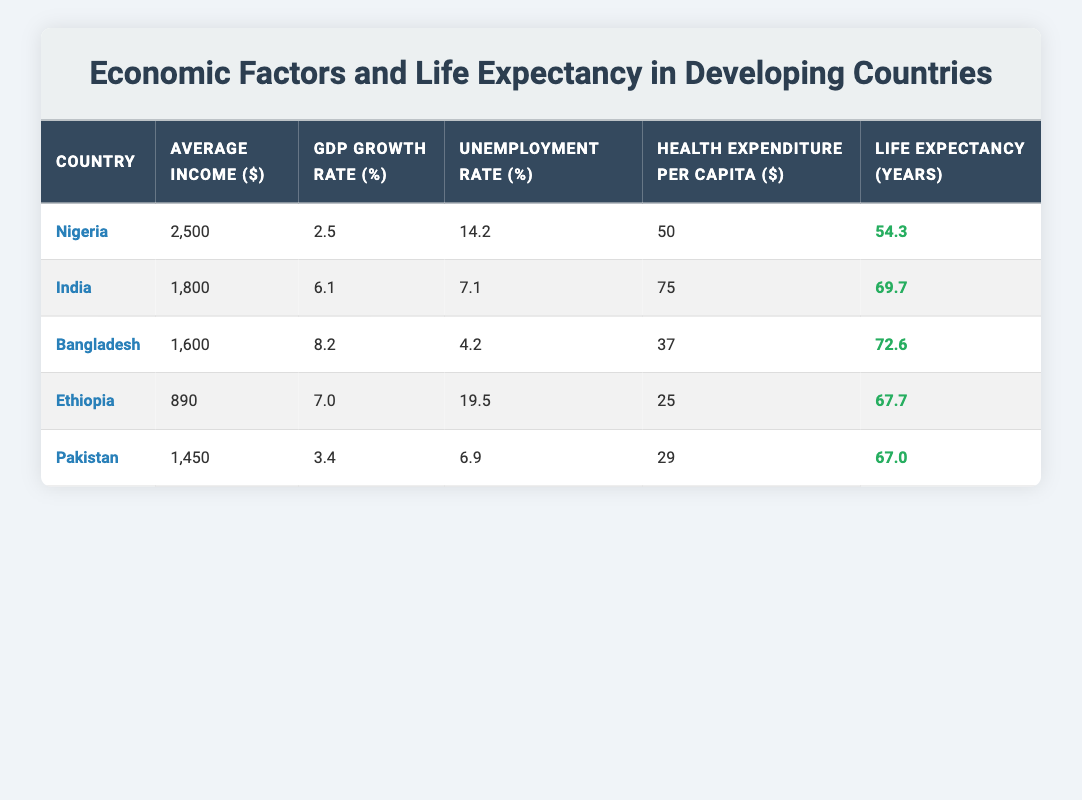What is the life expectancy of Nigeria? The life expectancy for Nigeria is listed in the last column of the row corresponding to Nigeria, which shows 54.3 years.
Answer: 54.3 Which country has the highest average income? By comparing the average income values in the second column, Nigeria has an average income of 2,500 dollars, which is higher than the amounts for India, Bangladesh, Ethiopia, and Pakistan.
Answer: Nigeria Is the unemployment rate for Pakistan lower than 10%? The unemployment rate for Pakistan is listed as 6.9%, which is indeed lower than 10%.
Answer: Yes What is the difference in life expectancy between Bangladesh and Nigeria? To find the difference, subtract Nigeria's life expectancy (54.3 years) from Bangladesh's (72.6 years): 72.6 - 54.3 = 18.3 years.
Answer: 18.3 What is the average health expenditure per capita for all countries listed? To calculate the average, sum the health expenditure per capita for all countries (50 + 75 + 37 + 25 + 29 = 216) and then divide by the number of countries (5): 216/5 = 43.2.
Answer: 43.2 Does Ethiopia have a higher GDP growth rate than Nigeria? The GDP growth rate of Ethiopia (7.0%) is compared to Nigeria's (2.5%) in the table, and since 7.0% is greater than 2.5%, the statement is true.
Answer: Yes Which country has the lowest life expectancy and what is that value? By looking at the life expectancy values in the last column, Nigeria has the lowest life expectancy at 54.3 years. This value is verified by identifying the record that is the minimum among the listed countries.
Answer: 54.3 If we consider the highest GDP growth rate from the table, what is the corresponding country? The GDP growth rates are compared across all the countries listed, and Bangladesh has the highest rate of 8.2%. This information is found in the third column of the row for Bangladesh.
Answer: Bangladesh Which countries have a health expenditure per capita greater than 30 dollars? By examining the health expenditure values, India (75), Bangladesh (37), and Pakistan (29) are identified as having expenditures above 30 dollars, as their corresponding values are greater.
Answer: India and Bangladesh 